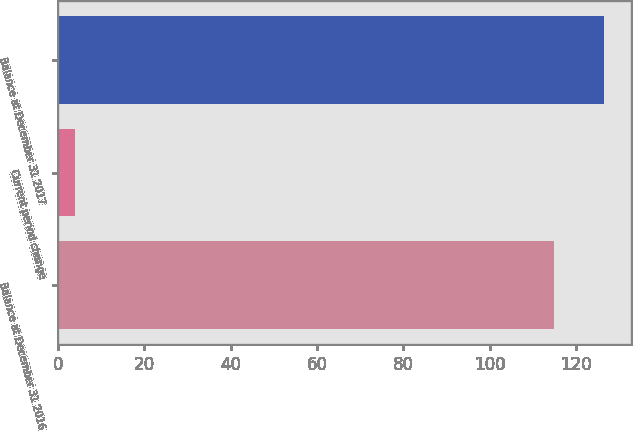Convert chart. <chart><loc_0><loc_0><loc_500><loc_500><bar_chart><fcel>Balance at December 31 2016<fcel>Current period change<fcel>Balance at December 31 2017<nl><fcel>115<fcel>4<fcel>126.5<nl></chart> 